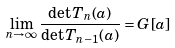<formula> <loc_0><loc_0><loc_500><loc_500>\lim _ { n \to \infty } \frac { \det T _ { n } ( a ) } { \det T _ { n - 1 } ( a ) } = G [ a ]</formula> 